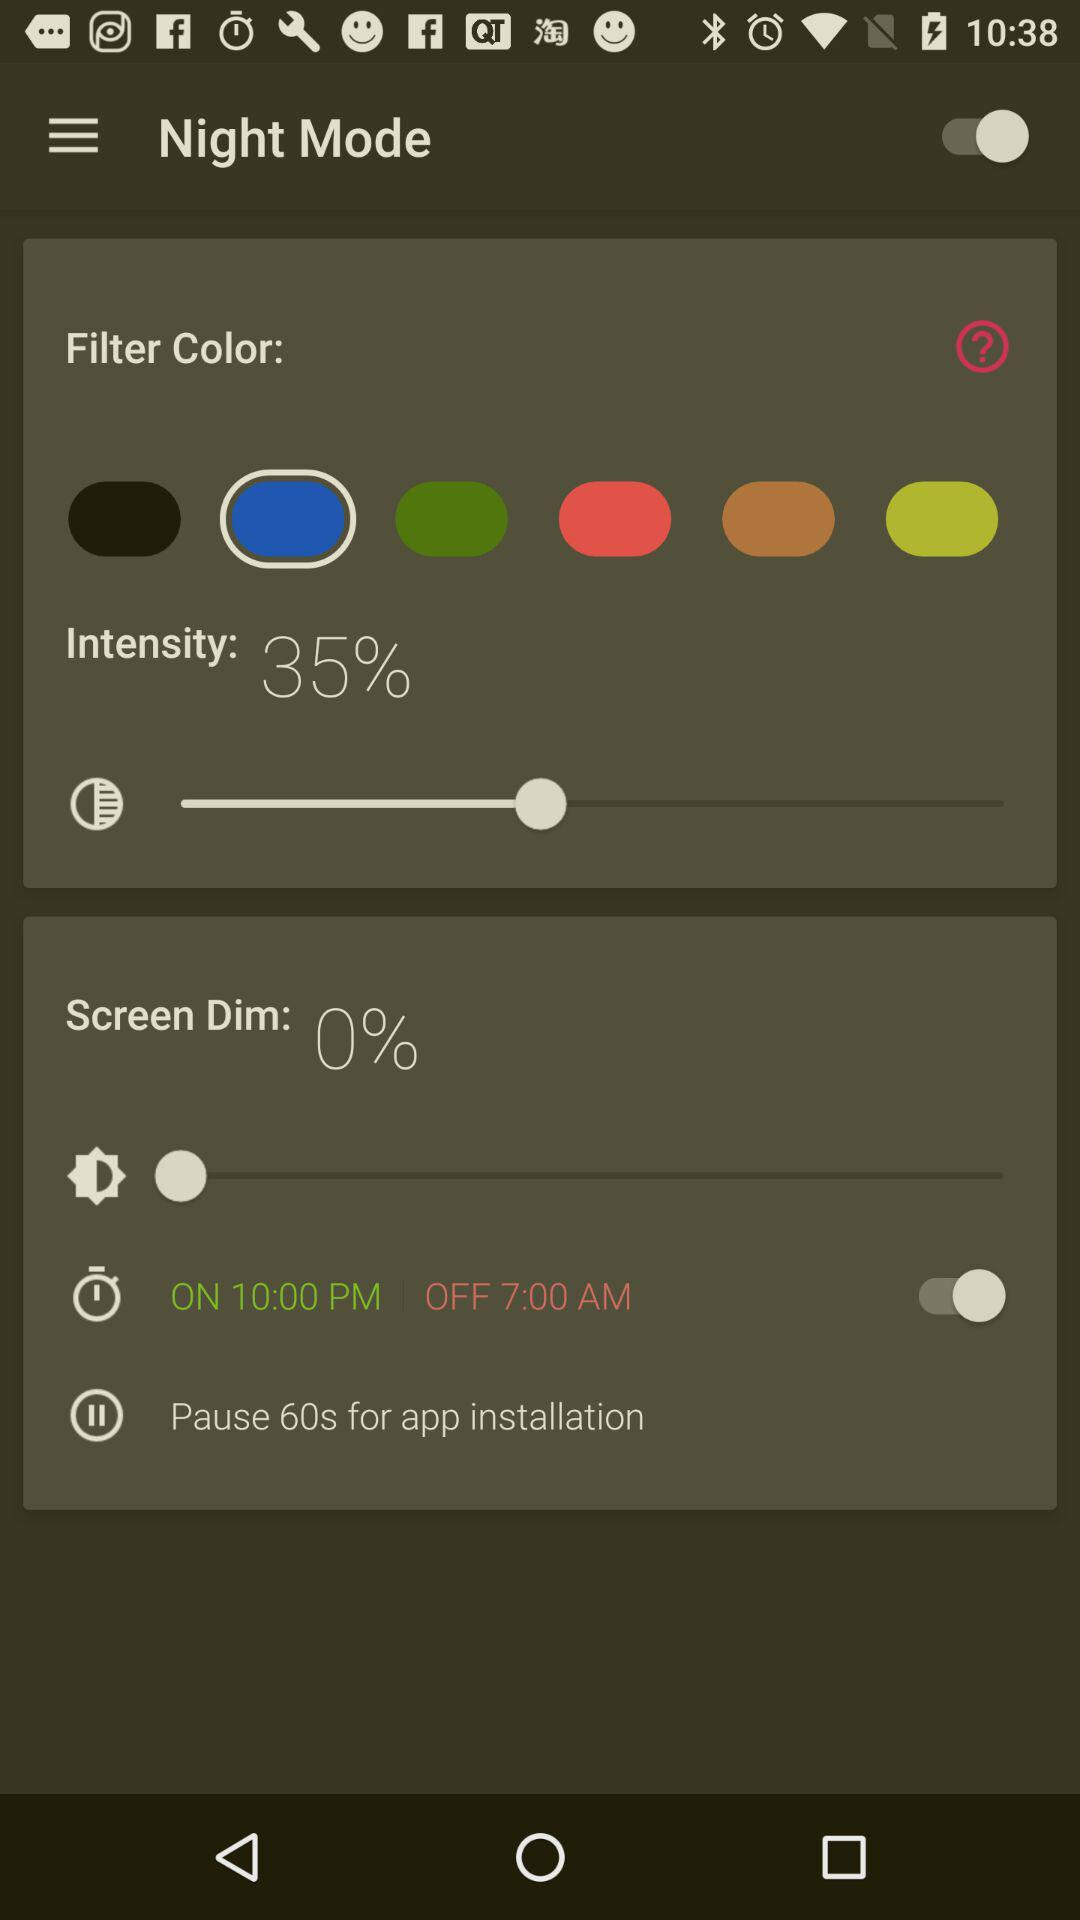What is the intensity percentage? The intensity percentage is 35. 